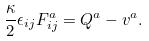Convert formula to latex. <formula><loc_0><loc_0><loc_500><loc_500>\frac { \kappa } { 2 } \epsilon _ { i j } F ^ { a } _ { i j } = Q ^ { a } - v ^ { a } .</formula> 